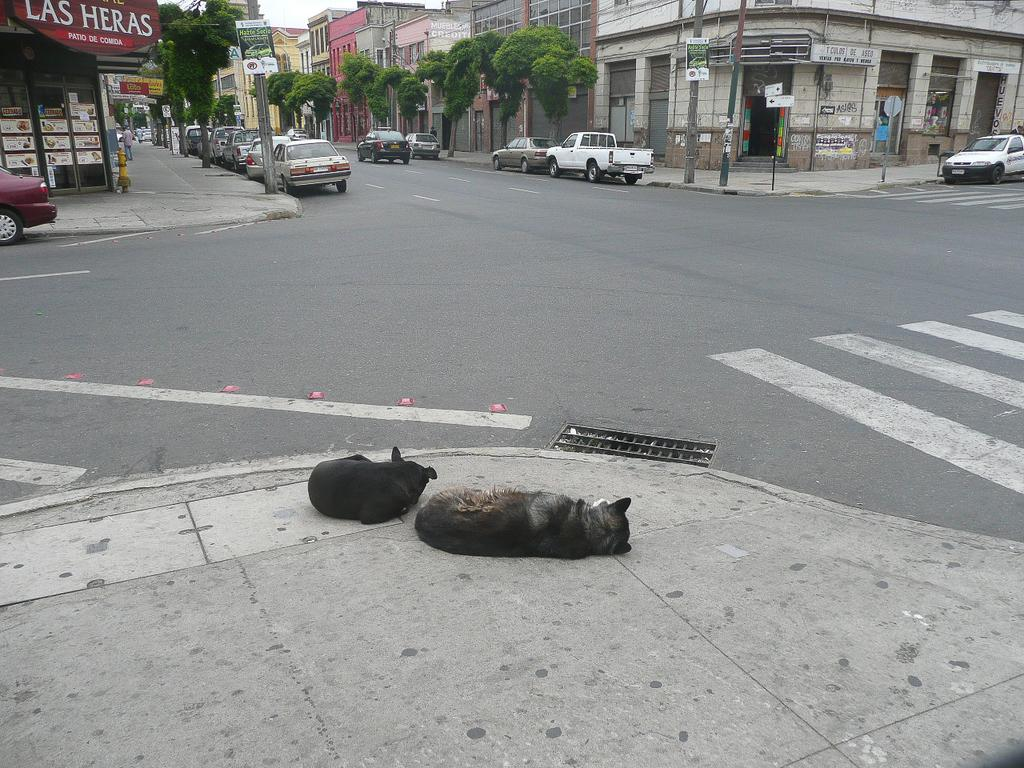What animals are lying on the road in the image? There are two dogs lying on the road in the image. What types of vehicles are present on either side of the road? Motor vehicles are present on either side of the road in the image. What structures can be seen in the image? There are stalls, name boards, trees, buildings, and electric poles visible in the image. What part of the natural environment is visible in the image? Trees and the sky are visible in the image. What type of cord is being used to power the tree in the image? There is no tree being powered by a cord in the image. 